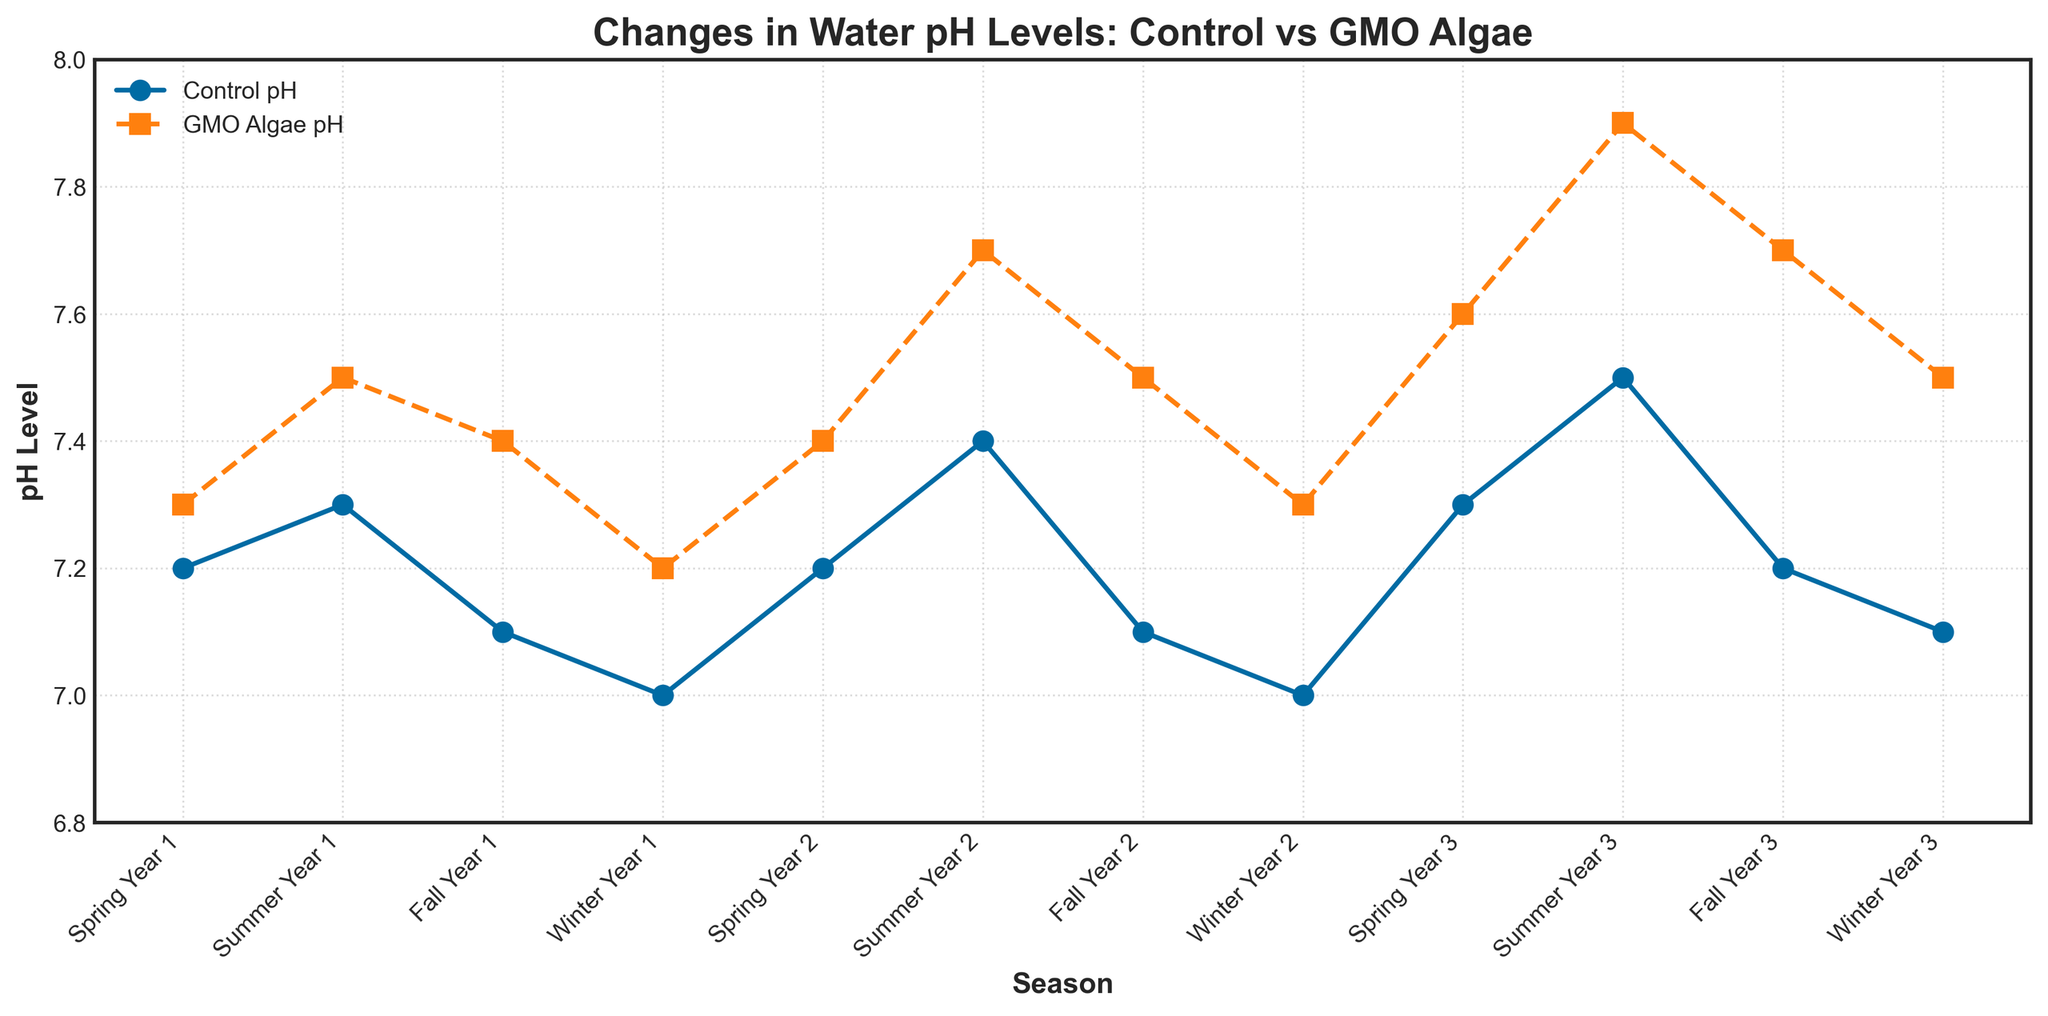What season and year showed the highest pH level in water exposed to GMO algae? The line for GMO Algae pH exhibits the highest point during Summer Year 3.
Answer: Summer Year 3 How do the pH levels of control and GMO algae conditions compare in Fall Year 2? Look at the pH level points for Fall Year 2 on both lines. The Control pH is at 7.1 while the GMO Algae pH is at 7.5.
Answer: Control: 7.1, GMO Algae: 7.5 What is the average pH level for the GMO algae condition over the three Spring seasons? Add the pH levels for Spring Year 1, Spring Year 2, and Spring Year 3 under the GMO Algae pH line (7.3, 7.4, 7.6) and divide by 3. \((7.3 + 7.4 + 7.6)/3 = 7.43\)
Answer: 7.43 During which season and year is the difference between Control pH and GMO Algae pH the smallest? Calculate the difference for each season and year by subtracting Control pH from GMO Algae pH, and identify the smallest difference. The smallest difference is 0.1 in Winter Year 1.
Answer: Winter Year 1 Did the pH level for the control condition change from Winter Year 1 to Winter Year 3? Compare the pH levels in Winter Year 1 (7.0) and Winter Year 3 (7.1) for the Control pH. There is a slight increase from 7.0 to 7.1.
Answer: Yes What trend can be observed in the pH levels of water exposed to GMO algae across the different Summer seasons? Follow the GMO Algae pH line across Summer Year 1, Summer Year 2, and Summer Year 3. The values are 7.5, 7.7, and 7.9, showing an increasing trend.
Answer: Increasing trend What is the median pH level for the control condition across all the recorded seasons? List all the Control pH values: 7.2, 7.3, 7.1, 7.0, 7.2, 7.4, 7.1, 7.0, 7.3, 7.5, 7.2, 7.1. Sort them and take the middle values: 7.1, 7.1, 7.1, 7.1, 7.2, 7.2, 7.2, 7.2, 7.3, 7.3, 7.4, 7.5. The median is \((7.2 + 7.2)/2 = 7.2\)
Answer: 7.2 How many seasons did the Control pH drop below 7.1? Identify the Control pH values that are below 7.1. The values below are in Winter Year 1 (7.0), Winter Year 2 (7.0). There are 2 seasons.
Answer: 2 Which season shows the largest difference between the Control pH and GMO Algae pH? Compute the differences for each season. The largest difference is in Summer Year 3: 7.9 - 7.5 = 0.4.
Answer: Summer Year 3 